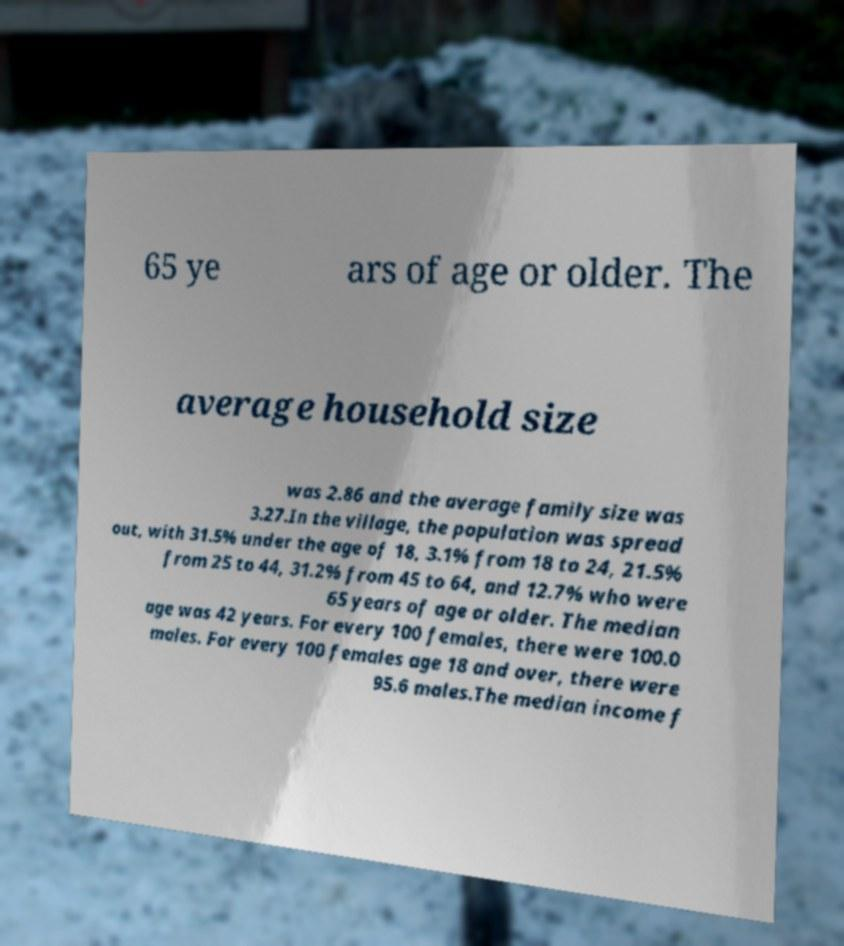Can you read and provide the text displayed in the image?This photo seems to have some interesting text. Can you extract and type it out for me? 65 ye ars of age or older. The average household size was 2.86 and the average family size was 3.27.In the village, the population was spread out, with 31.5% under the age of 18, 3.1% from 18 to 24, 21.5% from 25 to 44, 31.2% from 45 to 64, and 12.7% who were 65 years of age or older. The median age was 42 years. For every 100 females, there were 100.0 males. For every 100 females age 18 and over, there were 95.6 males.The median income f 